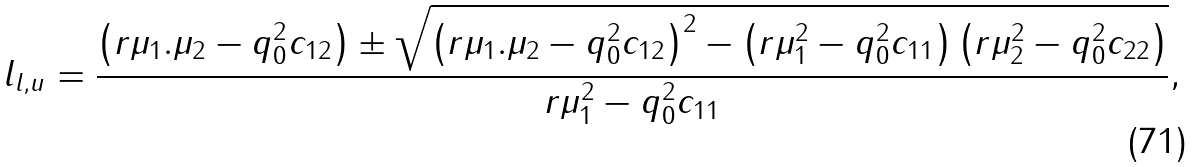<formula> <loc_0><loc_0><loc_500><loc_500>l _ { l , u } = \frac { \left ( r \mu _ { 1 } . \mu _ { 2 } - q _ { 0 } ^ { 2 } c _ { 1 2 } \right ) \pm \sqrt { \left ( r \mu _ { 1 } . \mu _ { 2 } - q _ { 0 } ^ { 2 } c _ { 1 2 } \right ) ^ { 2 } - \left ( r \mu _ { 1 } ^ { 2 } - q _ { 0 } ^ { 2 } c _ { 1 1 } \right ) \left ( r \mu _ { 2 } ^ { 2 } - q _ { 0 } ^ { 2 } c _ { 2 2 } \right ) } } { r \mu _ { 1 } ^ { 2 } - q _ { 0 } ^ { 2 } c _ { 1 1 } } ,</formula> 